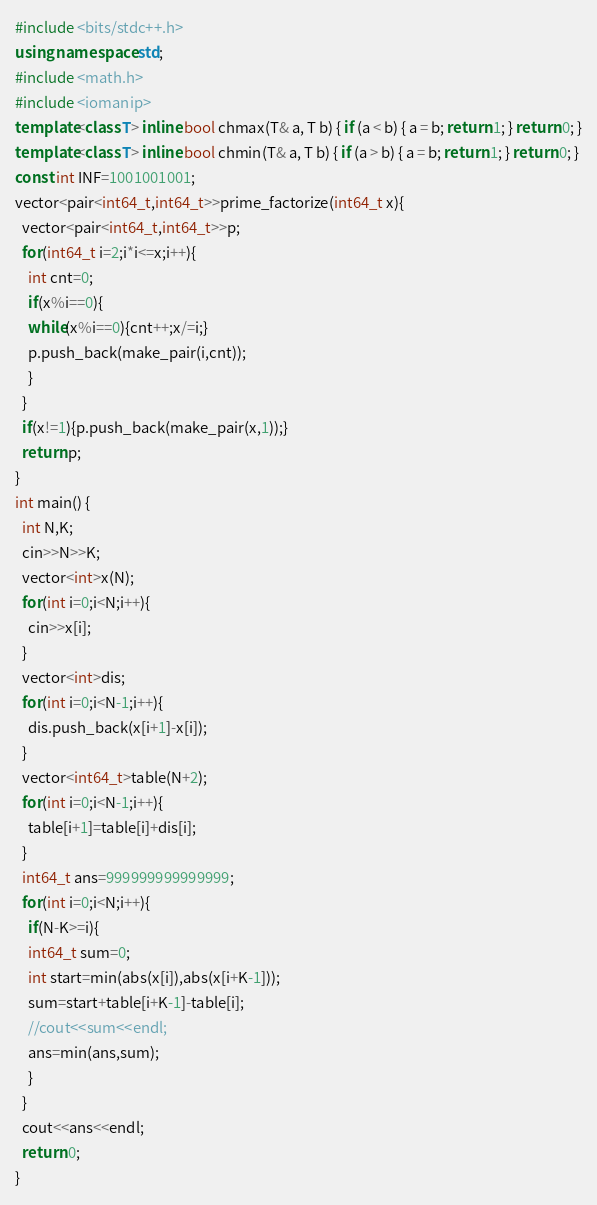<code> <loc_0><loc_0><loc_500><loc_500><_C++_>#include <bits/stdc++.h>
using namespace std;
#include <math.h>
#include <iomanip>
template<class T> inline bool chmax(T& a, T b) { if (a < b) { a = b; return 1; } return 0; }
template<class T> inline bool chmin(T& a, T b) { if (a > b) { a = b; return 1; } return 0; }
const int INF=1001001001;
vector<pair<int64_t,int64_t>>prime_factorize(int64_t x){
  vector<pair<int64_t,int64_t>>p;
  for(int64_t i=2;i*i<=x;i++){
    int cnt=0;
    if(x%i==0){
    while(x%i==0){cnt++;x/=i;}
    p.push_back(make_pair(i,cnt));
    }
  }
  if(x!=1){p.push_back(make_pair(x,1));}
  return p; 
}
int main() {
  int N,K;
  cin>>N>>K;
  vector<int>x(N);
  for(int i=0;i<N;i++){
    cin>>x[i];
  }
  vector<int>dis;
  for(int i=0;i<N-1;i++){
    dis.push_back(x[i+1]-x[i]);
  }
  vector<int64_t>table(N+2);
  for(int i=0;i<N-1;i++){
    table[i+1]=table[i]+dis[i];
  }
  int64_t ans=999999999999999;
  for(int i=0;i<N;i++){
    if(N-K>=i){
    int64_t sum=0;
    int start=min(abs(x[i]),abs(x[i+K-1]));
    sum=start+table[i+K-1]-table[i];
    //cout<<sum<<endl;
    ans=min(ans,sum);
    }
  }
  cout<<ans<<endl;
  return 0;
}</code> 